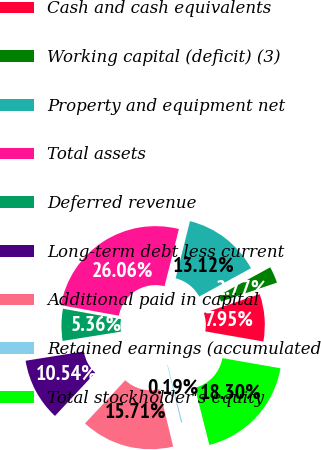<chart> <loc_0><loc_0><loc_500><loc_500><pie_chart><fcel>Cash and cash equivalents<fcel>Working capital (deficit) (3)<fcel>Property and equipment net<fcel>Total assets<fcel>Deferred revenue<fcel>Long-term debt less current<fcel>Additional paid in capital<fcel>Retained earnings (accumulated<fcel>Total stockholder's equity<nl><fcel>7.95%<fcel>2.77%<fcel>13.12%<fcel>26.06%<fcel>5.36%<fcel>10.54%<fcel>15.71%<fcel>0.19%<fcel>18.3%<nl></chart> 